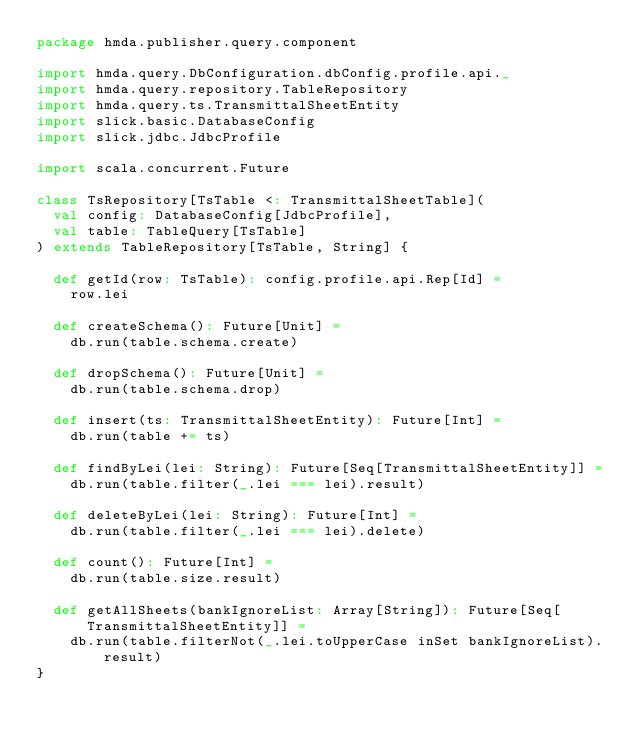<code> <loc_0><loc_0><loc_500><loc_500><_Scala_>package hmda.publisher.query.component

import hmda.query.DbConfiguration.dbConfig.profile.api._
import hmda.query.repository.TableRepository
import hmda.query.ts.TransmittalSheetEntity
import slick.basic.DatabaseConfig
import slick.jdbc.JdbcProfile

import scala.concurrent.Future

class TsRepository[TsTable <: TransmittalSheetTable](
  val config: DatabaseConfig[JdbcProfile],
  val table: TableQuery[TsTable]
) extends TableRepository[TsTable, String] {

  def getId(row: TsTable): config.profile.api.Rep[Id] =
    row.lei

  def createSchema(): Future[Unit] =
    db.run(table.schema.create)

  def dropSchema(): Future[Unit] =
    db.run(table.schema.drop)

  def insert(ts: TransmittalSheetEntity): Future[Int] =
    db.run(table += ts)

  def findByLei(lei: String): Future[Seq[TransmittalSheetEntity]] =
    db.run(table.filter(_.lei === lei).result)

  def deleteByLei(lei: String): Future[Int] =
    db.run(table.filter(_.lei === lei).delete)

  def count(): Future[Int] =
    db.run(table.size.result)

  def getAllSheets(bankIgnoreList: Array[String]): Future[Seq[TransmittalSheetEntity]] =
    db.run(table.filterNot(_.lei.toUpperCase inSet bankIgnoreList).result)
}</code> 